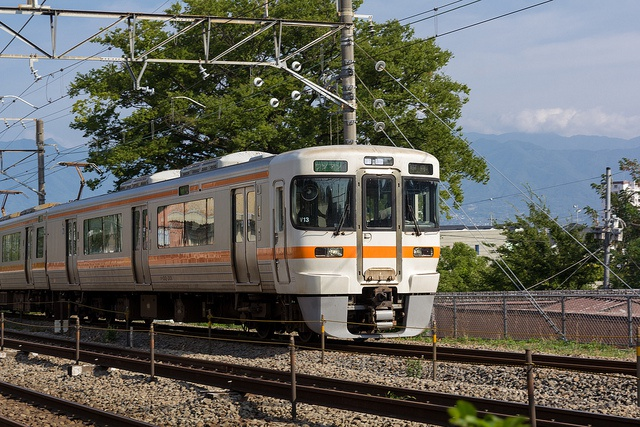Describe the objects in this image and their specific colors. I can see a train in darkgray, black, gray, and lightgray tones in this image. 